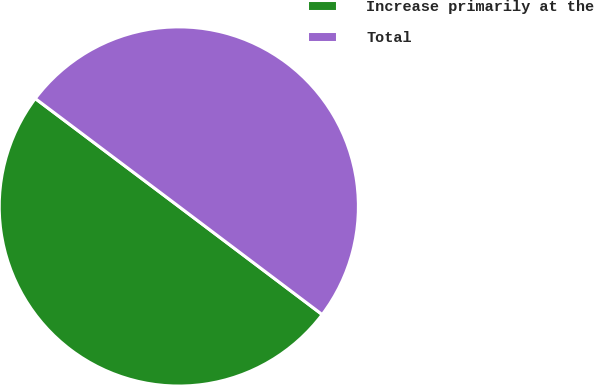<chart> <loc_0><loc_0><loc_500><loc_500><pie_chart><fcel>Increase primarily at the<fcel>Total<nl><fcel>49.98%<fcel>50.02%<nl></chart> 